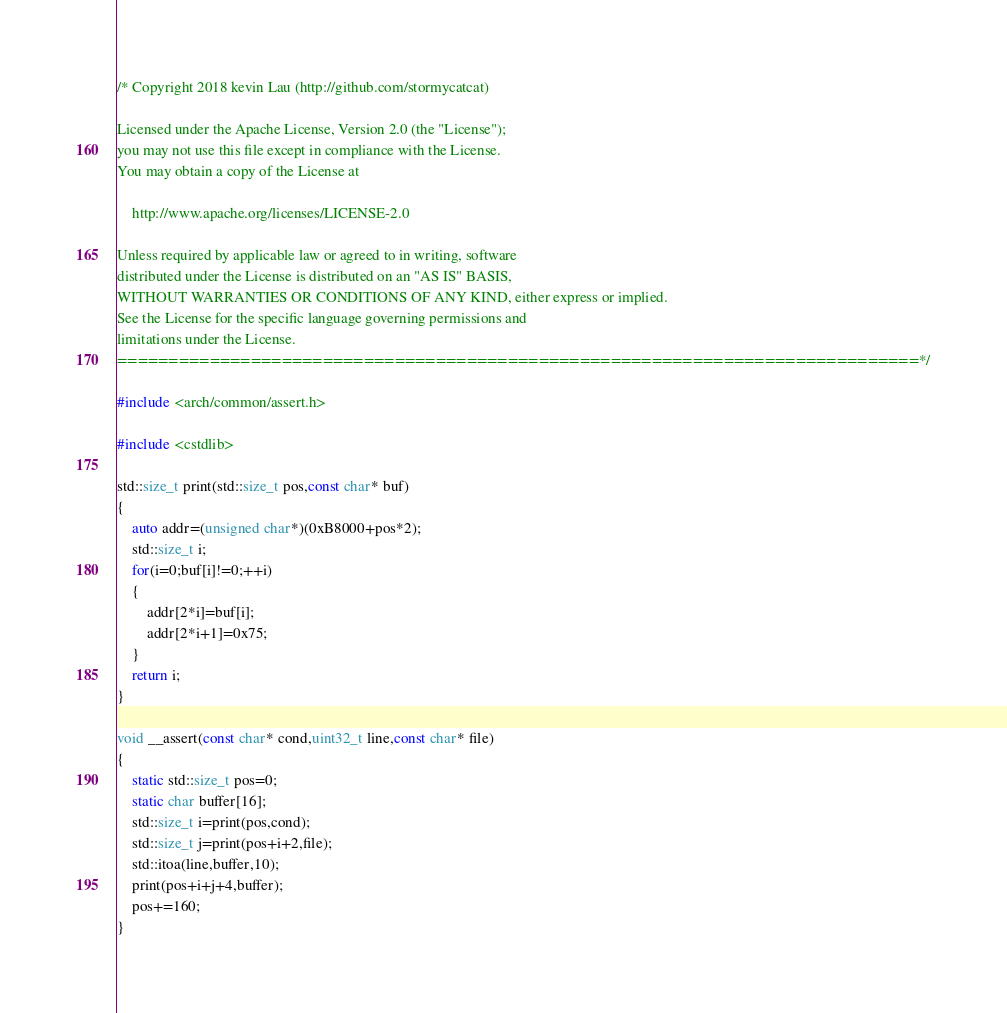Convert code to text. <code><loc_0><loc_0><loc_500><loc_500><_C++_>/* Copyright 2018 kevin Lau (http://github.com/stormycatcat)

Licensed under the Apache License, Version 2.0 (the "License");
you may not use this file except in compliance with the License.
You may obtain a copy of the License at

    http://www.apache.org/licenses/LICENSE-2.0

Unless required by applicable law or agreed to in writing, software
distributed under the License is distributed on an "AS IS" BASIS,
WITHOUT WARRANTIES OR CONDITIONS OF ANY KIND, either express or implied.
See the License for the specific language governing permissions and
limitations under the License.
==============================================================================*/

#include <arch/common/assert.h>

#include <cstdlib>

std::size_t print(std::size_t pos,const char* buf)
{
    auto addr=(unsigned char*)(0xB8000+pos*2);
    std::size_t i;
    for(i=0;buf[i]!=0;++i)
    {
        addr[2*i]=buf[i];
        addr[2*i+1]=0x75;
    }
    return i;
}

void __assert(const char* cond,uint32_t line,const char* file)
{
    static std::size_t pos=0;
    static char buffer[16];
    std::size_t i=print(pos,cond);
    std::size_t j=print(pos+i+2,file);
    std::itoa(line,buffer,10);
    print(pos+i+j+4,buffer);
    pos+=160;
}
</code> 